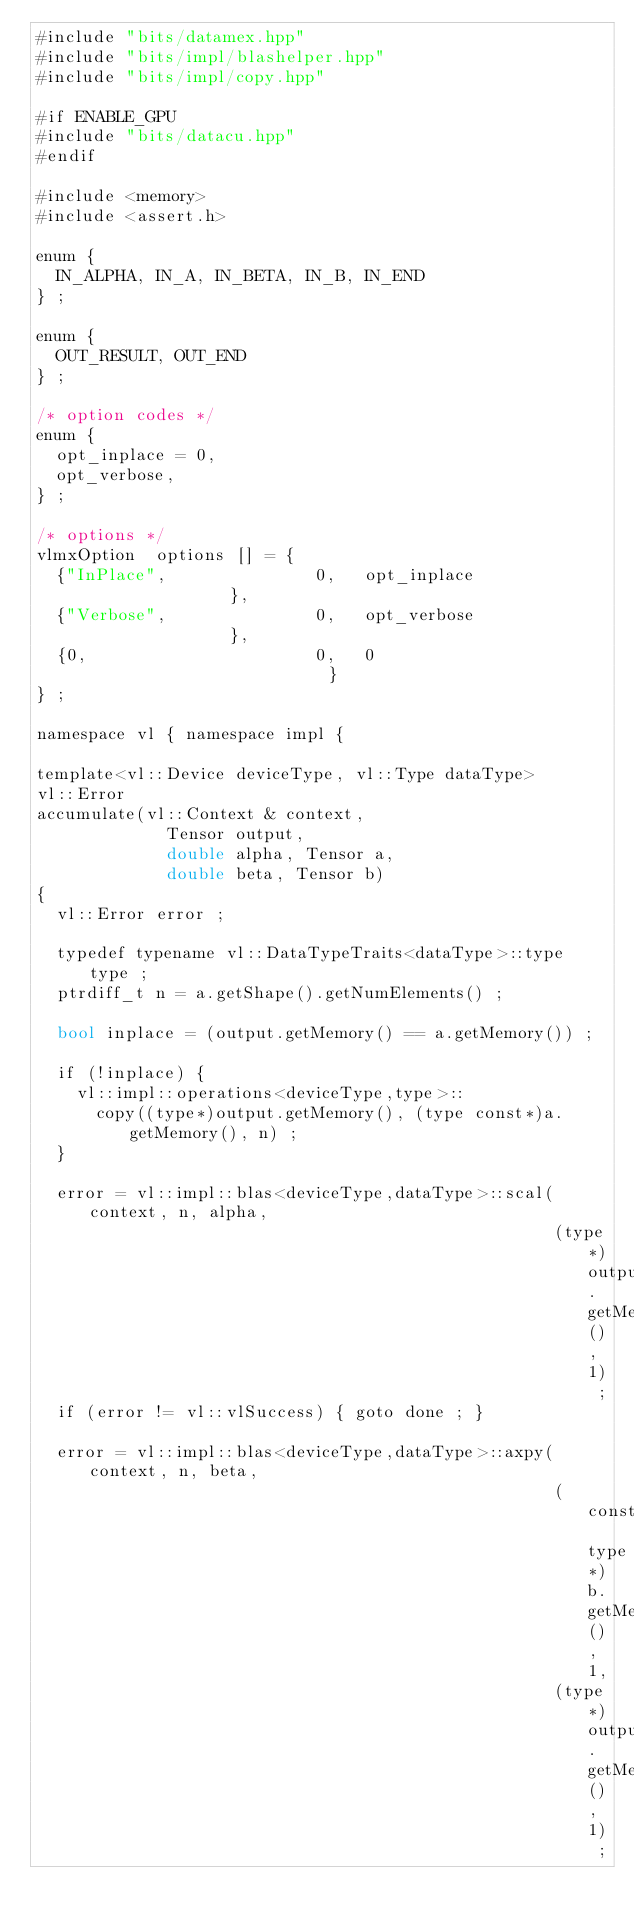Convert code to text. <code><loc_0><loc_0><loc_500><loc_500><_Cuda_>#include "bits/datamex.hpp"
#include "bits/impl/blashelper.hpp"
#include "bits/impl/copy.hpp"

#if ENABLE_GPU
#include "bits/datacu.hpp"
#endif

#include <memory>
#include <assert.h>

enum {
  IN_ALPHA, IN_A, IN_BETA, IN_B, IN_END
} ;

enum {
  OUT_RESULT, OUT_END
} ;

/* option codes */
enum {
  opt_inplace = 0,
  opt_verbose,
} ;

/* options */
vlmxOption  options [] = {
  {"InPlace",               0,   opt_inplace               },
  {"Verbose",               0,   opt_verbose               },
  {0,                       0,   0                         }
} ;

namespace vl { namespace impl {

template<vl::Device deviceType, vl::Type dataType>
vl::Error
accumulate(vl::Context & context,
             Tensor output,
             double alpha, Tensor a,
             double beta, Tensor b)
{
  vl::Error error ;

  typedef typename vl::DataTypeTraits<dataType>::type type ;
  ptrdiff_t n = a.getShape().getNumElements() ;

  bool inplace = (output.getMemory() == a.getMemory()) ;

  if (!inplace) {
    vl::impl::operations<deviceType,type>::
      copy((type*)output.getMemory(), (type const*)a.getMemory(), n) ;
  }

  error = vl::impl::blas<deviceType,dataType>::scal(context, n, alpha,
                                                    (type*)output.getMemory(), 1) ;
  if (error != vl::vlSuccess) { goto done ; }

  error = vl::impl::blas<deviceType,dataType>::axpy(context, n, beta,
                                                    (const type*)b.getMemory(), 1,
                                                    (type*)output.getMemory(), 1) ;</code> 